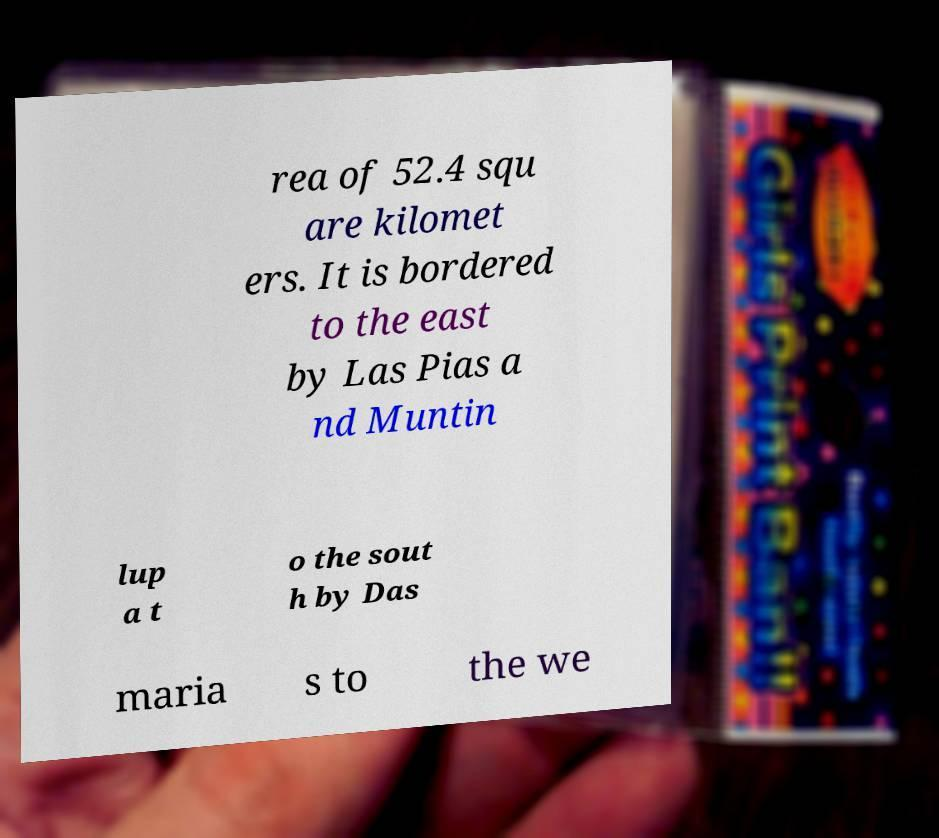Could you assist in decoding the text presented in this image and type it out clearly? rea of 52.4 squ are kilomet ers. It is bordered to the east by Las Pias a nd Muntin lup a t o the sout h by Das maria s to the we 